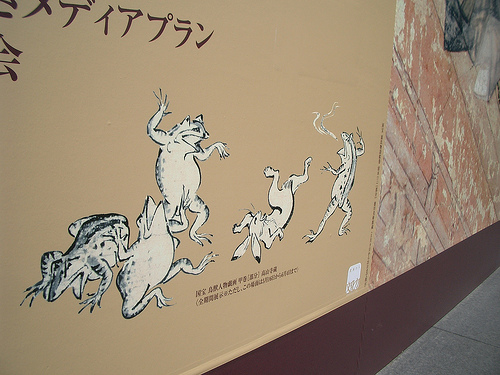<image>
Can you confirm if the frog is behind the rabbit? No. The frog is not behind the rabbit. From this viewpoint, the frog appears to be positioned elsewhere in the scene. 